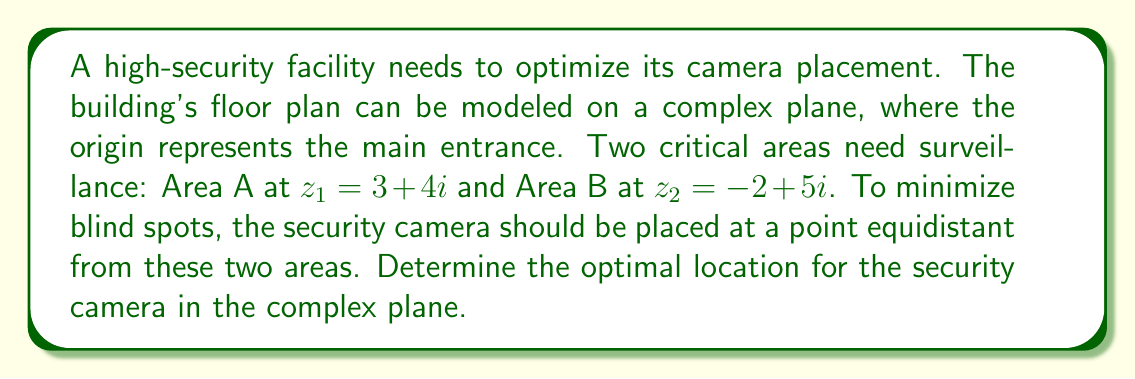Can you answer this question? To solve this problem, we need to find a point that is equidistant from the two given points on the complex plane. This point will be on the perpendicular bisector of the line segment connecting $z_1$ and $z_2$.

Step 1: Calculate the midpoint of the line segment connecting $z_1$ and $z_2$.
Midpoint = $\frac{z_1 + z_2}{2} = \frac{(3+4i) + (-2+5i)}{2} = \frac{1+9i}{2} = 0.5 + 4.5i$

Step 2: Calculate the vector from $z_1$ to $z_2$.
$\vec{v} = z_2 - z_1 = (-2+5i) - (3+4i) = -5+i$

Step 3: Find the perpendicular vector by multiplying $\vec{v}$ by $i$.
$\vec{v}_{\perp} = i(-5+i) = 1+5i$

Step 4: Normalize $\vec{v}_{\perp}$ to get a unit vector.
$\|\vec{v}_{\perp}\| = \sqrt{1^2 + 5^2} = \sqrt{26}$
$\vec{u} = \frac{\vec{v}_{\perp}}{\|\vec{v}_{\perp}\|} = \frac{1+5i}{\sqrt{26}}$

Step 5: The optimal camera location will be on the line passing through the midpoint in the direction of $\vec{u}$. We can represent this line parametrically as:

$z(t) = (0.5 + 4.5i) + t\frac{1+5i}{\sqrt{26}}$, where $t$ is a real number.

The security expert can choose any point on this line, depending on the desired distance from the midpoint. A common choice would be $t=0$, which places the camera at the midpoint itself.
Answer: The optimal location for the security camera is on the line given by:

$$z(t) = (0.5 + 4.5i) + t\frac{1+5i}{\sqrt{26}}$$

where $t$ is a real number. The midpoint $(0.5 + 4.5i)$ is a practical choice, corresponding to $t=0$. 